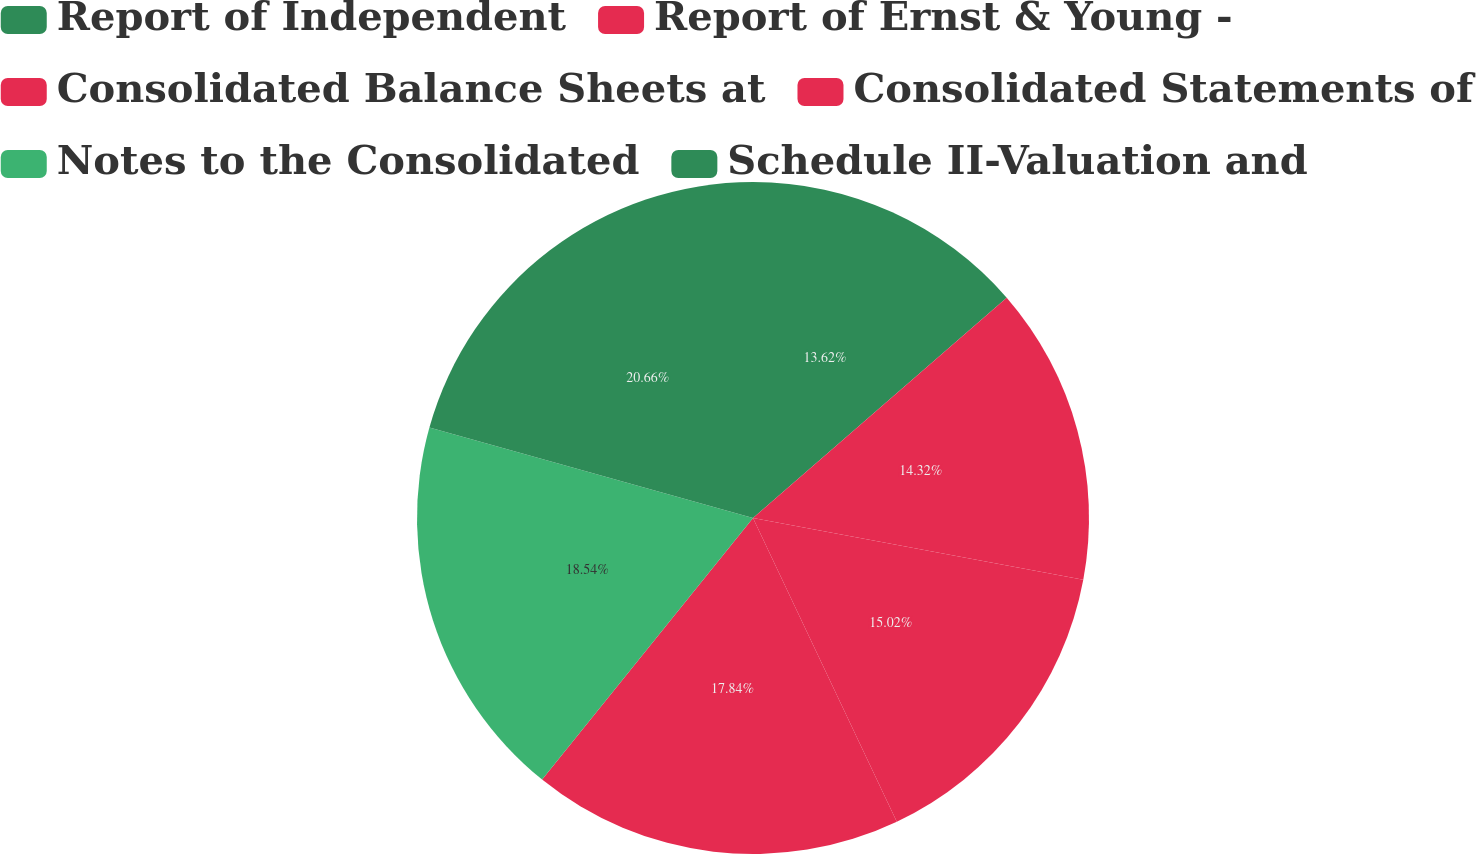Convert chart to OTSL. <chart><loc_0><loc_0><loc_500><loc_500><pie_chart><fcel>Report of Independent<fcel>Report of Ernst & Young -<fcel>Consolidated Balance Sheets at<fcel>Consolidated Statements of<fcel>Notes to the Consolidated<fcel>Schedule II-Valuation and<nl><fcel>13.62%<fcel>14.32%<fcel>15.02%<fcel>17.84%<fcel>18.54%<fcel>20.66%<nl></chart> 